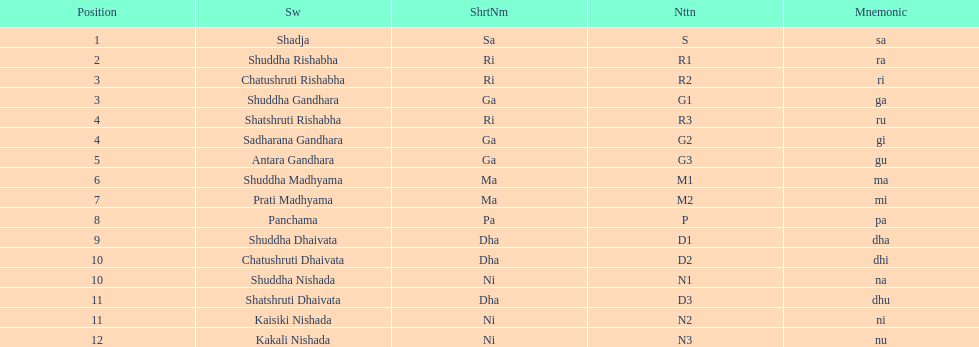What is the name of the swara that holds the first position? Shadja. 